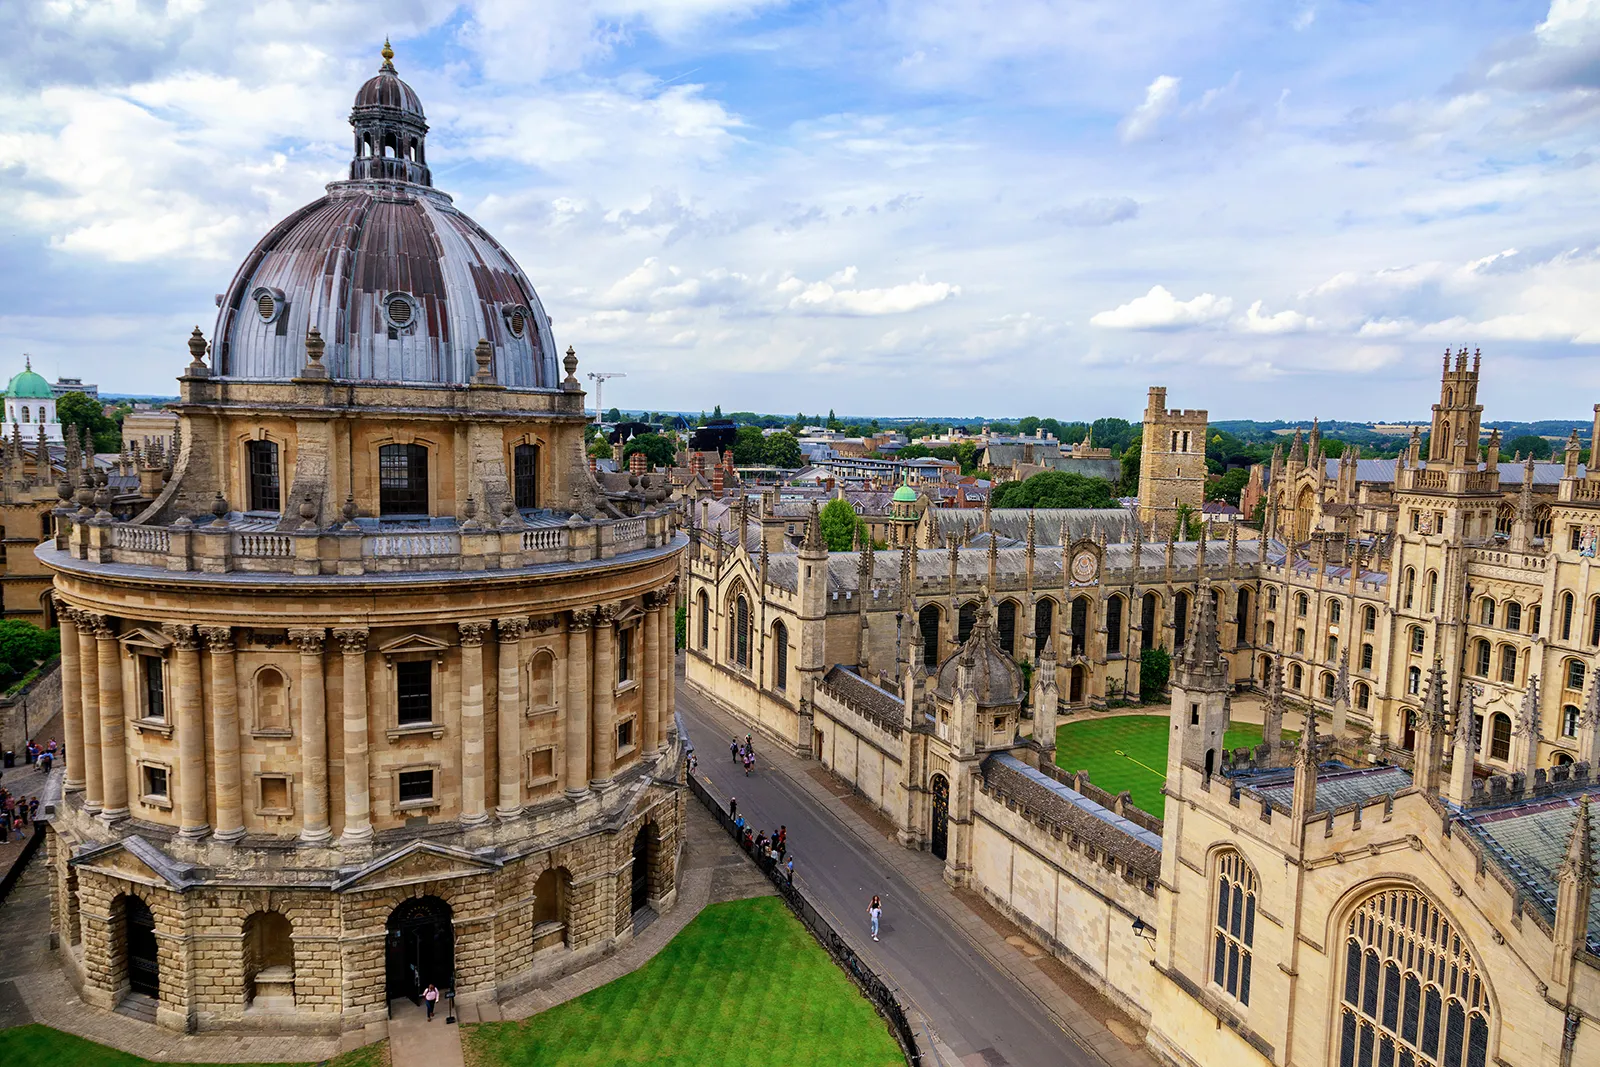Can you describe what it might feel like to study in this environment? Studying in this environment would likely be an awe-inspiring experience. The Radcliffe Camera provides an almost ethereal atmosphere with its grandeur and historical significance. As a student, you would be surrounded by centuries-old architectural beauty and the soothing green lawns, fostering a sense of academic and intellectual pursuit. The tranquil atmosphere, punctuated by the occasional rustling of leaves and the distant chimes of the university's bells, would create an ideal setting for deep, contemplative study. Can you imagine a day in the life of a student at Oxford University? A day in the life of an Oxford University student might begin with a serene walk through the historic university gardens, under the canopy of ancient trees, before attending a morning lecture in one of the grand, historic lecture halls. After lectures, the student could retire to the Radcliffe Camera to study, surrounded by the timeless magnificence of the architectural masterpiece. Lunch might be a quick meal in one of the bustling cafes nearby, followed by a tutorial session, where the student engages in intense intellectual discussions with a distinguished professor. The evening could be spent at a local pub, unwinding with friends, before heading back to the dormitory, reflecting on the day’s scholarly pursuits. Imagine a secret passage discovered under this building. What treasures or mysteries might it hold? In a twist of imagination, discovering a secret passage beneath the Radcliffe Camera could lead to a hidden chamber filled with ancient manuscripts and forbidden knowledge, guarded for centuries by a clandestine society. These manuscripts could reveal forgotten spells, alchemical recipes, or detailed maps of long-lost civilizations. As students uncover these treasures, they might find themselves entwined in a web of historical intrigue and mystery, unlocking secrets that could change the course of history. 